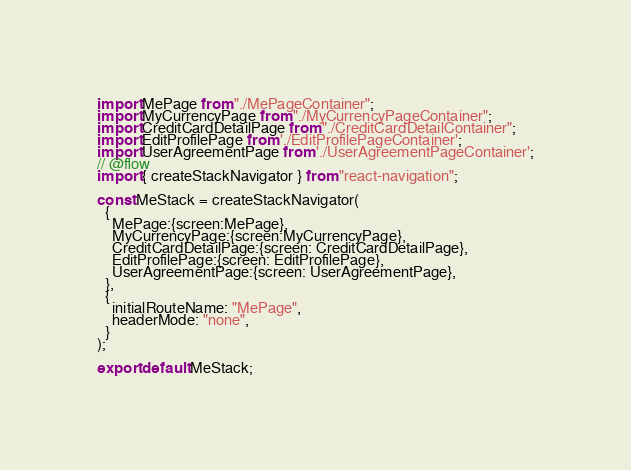Convert code to text. <code><loc_0><loc_0><loc_500><loc_500><_JavaScript_>import MePage from "./MePageContainer";
import MyCurrencyPage from "./MyCurrencyPageContainer";
import CreditCardDetailPage from "./CreditCardDetailContainer";
import EditProfilePage from './EditProfilePageContainer';
import UserAgreementPage from './UserAgreementPageContainer';
// @flow
import { createStackNavigator } from "react-navigation";

const MeStack = createStackNavigator(
  {
    MePage:{screen:MePage},
    MyCurrencyPage:{screen:MyCurrencyPage},
    CreditCardDetailPage:{screen: CreditCardDetailPage},
    EditProfilePage:{screen: EditProfilePage},
    UserAgreementPage:{screen: UserAgreementPage},
  },
  {
    initialRouteName: "MePage",
    headerMode: "none",
  }
);

export default MeStack;
</code> 